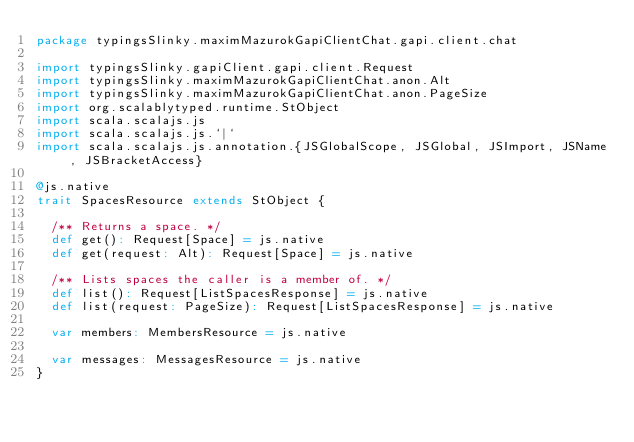Convert code to text. <code><loc_0><loc_0><loc_500><loc_500><_Scala_>package typingsSlinky.maximMazurokGapiClientChat.gapi.client.chat

import typingsSlinky.gapiClient.gapi.client.Request
import typingsSlinky.maximMazurokGapiClientChat.anon.Alt
import typingsSlinky.maximMazurokGapiClientChat.anon.PageSize
import org.scalablytyped.runtime.StObject
import scala.scalajs.js
import scala.scalajs.js.`|`
import scala.scalajs.js.annotation.{JSGlobalScope, JSGlobal, JSImport, JSName, JSBracketAccess}

@js.native
trait SpacesResource extends StObject {
  
  /** Returns a space. */
  def get(): Request[Space] = js.native
  def get(request: Alt): Request[Space] = js.native
  
  /** Lists spaces the caller is a member of. */
  def list(): Request[ListSpacesResponse] = js.native
  def list(request: PageSize): Request[ListSpacesResponse] = js.native
  
  var members: MembersResource = js.native
  
  var messages: MessagesResource = js.native
}
</code> 